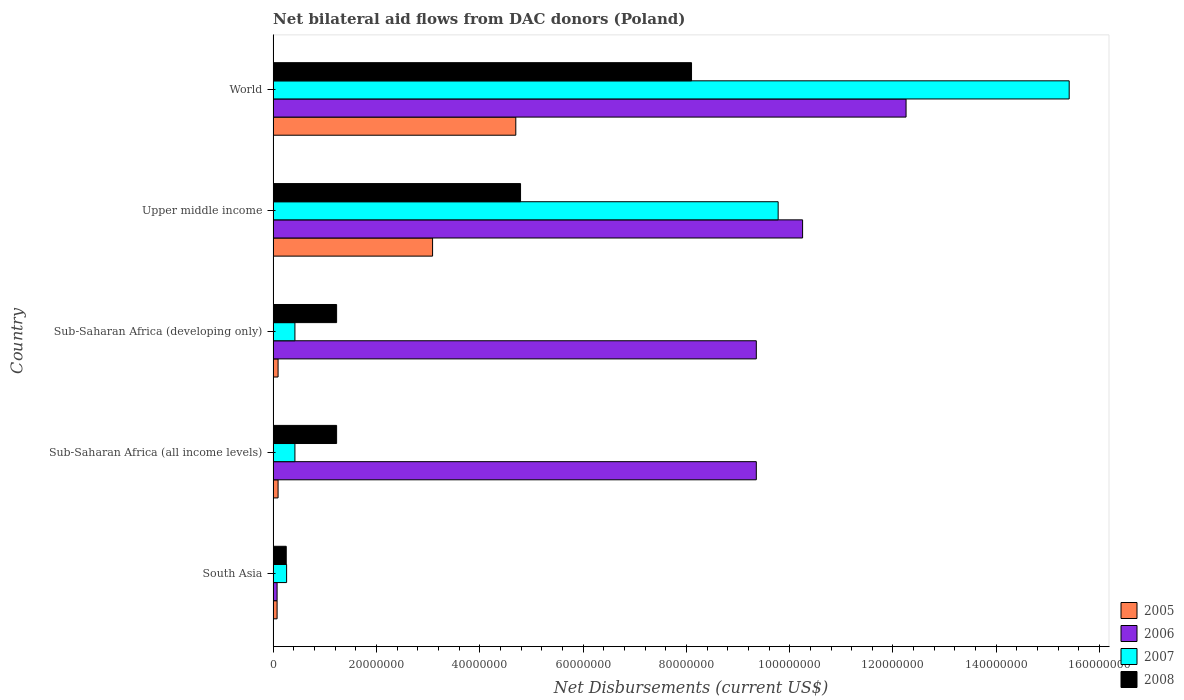How many groups of bars are there?
Provide a succinct answer. 5. Are the number of bars on each tick of the Y-axis equal?
Ensure brevity in your answer.  Yes. How many bars are there on the 1st tick from the top?
Ensure brevity in your answer.  4. How many bars are there on the 5th tick from the bottom?
Your answer should be very brief. 4. What is the label of the 3rd group of bars from the top?
Ensure brevity in your answer.  Sub-Saharan Africa (developing only). What is the net bilateral aid flows in 2005 in Sub-Saharan Africa (all income levels)?
Offer a terse response. 9.60e+05. Across all countries, what is the maximum net bilateral aid flows in 2008?
Offer a terse response. 8.10e+07. Across all countries, what is the minimum net bilateral aid flows in 2007?
Ensure brevity in your answer.  2.61e+06. In which country was the net bilateral aid flows in 2007 maximum?
Keep it short and to the point. World. What is the total net bilateral aid flows in 2005 in the graph?
Make the answer very short. 8.05e+07. What is the difference between the net bilateral aid flows in 2008 in Sub-Saharan Africa (developing only) and that in World?
Offer a very short reply. -6.87e+07. What is the difference between the net bilateral aid flows in 2007 in World and the net bilateral aid flows in 2008 in Upper middle income?
Make the answer very short. 1.06e+08. What is the average net bilateral aid flows in 2007 per country?
Offer a terse response. 5.26e+07. What is the difference between the net bilateral aid flows in 2008 and net bilateral aid flows in 2005 in South Asia?
Keep it short and to the point. 1.77e+06. What is the ratio of the net bilateral aid flows in 2007 in Sub-Saharan Africa (developing only) to that in Upper middle income?
Give a very brief answer. 0.04. What is the difference between the highest and the second highest net bilateral aid flows in 2007?
Offer a terse response. 5.63e+07. What is the difference between the highest and the lowest net bilateral aid flows in 2008?
Your answer should be compact. 7.85e+07. In how many countries, is the net bilateral aid flows in 2008 greater than the average net bilateral aid flows in 2008 taken over all countries?
Keep it short and to the point. 2. Is the sum of the net bilateral aid flows in 2008 in Upper middle income and World greater than the maximum net bilateral aid flows in 2007 across all countries?
Provide a short and direct response. No. What does the 1st bar from the top in Sub-Saharan Africa (all income levels) represents?
Make the answer very short. 2008. How many countries are there in the graph?
Keep it short and to the point. 5. What is the difference between two consecutive major ticks on the X-axis?
Ensure brevity in your answer.  2.00e+07. Are the values on the major ticks of X-axis written in scientific E-notation?
Offer a terse response. No. Does the graph contain any zero values?
Your answer should be very brief. No. Does the graph contain grids?
Ensure brevity in your answer.  No. How many legend labels are there?
Provide a short and direct response. 4. How are the legend labels stacked?
Your response must be concise. Vertical. What is the title of the graph?
Your response must be concise. Net bilateral aid flows from DAC donors (Poland). Does "1964" appear as one of the legend labels in the graph?
Your answer should be compact. No. What is the label or title of the X-axis?
Offer a very short reply. Net Disbursements (current US$). What is the Net Disbursements (current US$) of 2005 in South Asia?
Offer a very short reply. 7.70e+05. What is the Net Disbursements (current US$) of 2006 in South Asia?
Ensure brevity in your answer.  7.70e+05. What is the Net Disbursements (current US$) of 2007 in South Asia?
Your answer should be very brief. 2.61e+06. What is the Net Disbursements (current US$) of 2008 in South Asia?
Keep it short and to the point. 2.54e+06. What is the Net Disbursements (current US$) in 2005 in Sub-Saharan Africa (all income levels)?
Ensure brevity in your answer.  9.60e+05. What is the Net Disbursements (current US$) of 2006 in Sub-Saharan Africa (all income levels)?
Your answer should be compact. 9.35e+07. What is the Net Disbursements (current US$) of 2007 in Sub-Saharan Africa (all income levels)?
Your answer should be very brief. 4.22e+06. What is the Net Disbursements (current US$) in 2008 in Sub-Saharan Africa (all income levels)?
Ensure brevity in your answer.  1.23e+07. What is the Net Disbursements (current US$) of 2005 in Sub-Saharan Africa (developing only)?
Provide a short and direct response. 9.60e+05. What is the Net Disbursements (current US$) of 2006 in Sub-Saharan Africa (developing only)?
Your answer should be very brief. 9.35e+07. What is the Net Disbursements (current US$) in 2007 in Sub-Saharan Africa (developing only)?
Provide a succinct answer. 4.22e+06. What is the Net Disbursements (current US$) in 2008 in Sub-Saharan Africa (developing only)?
Offer a very short reply. 1.23e+07. What is the Net Disbursements (current US$) in 2005 in Upper middle income?
Offer a terse response. 3.09e+07. What is the Net Disbursements (current US$) in 2006 in Upper middle income?
Offer a terse response. 1.02e+08. What is the Net Disbursements (current US$) of 2007 in Upper middle income?
Provide a succinct answer. 9.78e+07. What is the Net Disbursements (current US$) in 2008 in Upper middle income?
Provide a succinct answer. 4.79e+07. What is the Net Disbursements (current US$) in 2005 in World?
Keep it short and to the point. 4.70e+07. What is the Net Disbursements (current US$) of 2006 in World?
Your response must be concise. 1.23e+08. What is the Net Disbursements (current US$) in 2007 in World?
Offer a terse response. 1.54e+08. What is the Net Disbursements (current US$) of 2008 in World?
Provide a short and direct response. 8.10e+07. Across all countries, what is the maximum Net Disbursements (current US$) of 2005?
Make the answer very short. 4.70e+07. Across all countries, what is the maximum Net Disbursements (current US$) of 2006?
Give a very brief answer. 1.23e+08. Across all countries, what is the maximum Net Disbursements (current US$) of 2007?
Provide a succinct answer. 1.54e+08. Across all countries, what is the maximum Net Disbursements (current US$) of 2008?
Keep it short and to the point. 8.10e+07. Across all countries, what is the minimum Net Disbursements (current US$) of 2005?
Keep it short and to the point. 7.70e+05. Across all countries, what is the minimum Net Disbursements (current US$) in 2006?
Offer a terse response. 7.70e+05. Across all countries, what is the minimum Net Disbursements (current US$) of 2007?
Your answer should be compact. 2.61e+06. Across all countries, what is the minimum Net Disbursements (current US$) in 2008?
Offer a very short reply. 2.54e+06. What is the total Net Disbursements (current US$) of 2005 in the graph?
Give a very brief answer. 8.05e+07. What is the total Net Disbursements (current US$) in 2006 in the graph?
Offer a very short reply. 4.13e+08. What is the total Net Disbursements (current US$) of 2007 in the graph?
Your answer should be compact. 2.63e+08. What is the total Net Disbursements (current US$) in 2008 in the graph?
Provide a succinct answer. 1.56e+08. What is the difference between the Net Disbursements (current US$) in 2006 in South Asia and that in Sub-Saharan Africa (all income levels)?
Your answer should be very brief. -9.28e+07. What is the difference between the Net Disbursements (current US$) in 2007 in South Asia and that in Sub-Saharan Africa (all income levels)?
Your response must be concise. -1.61e+06. What is the difference between the Net Disbursements (current US$) in 2008 in South Asia and that in Sub-Saharan Africa (all income levels)?
Offer a very short reply. -9.75e+06. What is the difference between the Net Disbursements (current US$) of 2005 in South Asia and that in Sub-Saharan Africa (developing only)?
Give a very brief answer. -1.90e+05. What is the difference between the Net Disbursements (current US$) in 2006 in South Asia and that in Sub-Saharan Africa (developing only)?
Your response must be concise. -9.28e+07. What is the difference between the Net Disbursements (current US$) of 2007 in South Asia and that in Sub-Saharan Africa (developing only)?
Provide a short and direct response. -1.61e+06. What is the difference between the Net Disbursements (current US$) in 2008 in South Asia and that in Sub-Saharan Africa (developing only)?
Ensure brevity in your answer.  -9.75e+06. What is the difference between the Net Disbursements (current US$) of 2005 in South Asia and that in Upper middle income?
Give a very brief answer. -3.01e+07. What is the difference between the Net Disbursements (current US$) of 2006 in South Asia and that in Upper middle income?
Your answer should be compact. -1.02e+08. What is the difference between the Net Disbursements (current US$) of 2007 in South Asia and that in Upper middle income?
Offer a very short reply. -9.52e+07. What is the difference between the Net Disbursements (current US$) in 2008 in South Asia and that in Upper middle income?
Keep it short and to the point. -4.54e+07. What is the difference between the Net Disbursements (current US$) of 2005 in South Asia and that in World?
Offer a terse response. -4.62e+07. What is the difference between the Net Disbursements (current US$) in 2006 in South Asia and that in World?
Your answer should be compact. -1.22e+08. What is the difference between the Net Disbursements (current US$) in 2007 in South Asia and that in World?
Offer a very short reply. -1.52e+08. What is the difference between the Net Disbursements (current US$) in 2008 in South Asia and that in World?
Ensure brevity in your answer.  -7.85e+07. What is the difference between the Net Disbursements (current US$) in 2005 in Sub-Saharan Africa (all income levels) and that in Sub-Saharan Africa (developing only)?
Your response must be concise. 0. What is the difference between the Net Disbursements (current US$) of 2007 in Sub-Saharan Africa (all income levels) and that in Sub-Saharan Africa (developing only)?
Give a very brief answer. 0. What is the difference between the Net Disbursements (current US$) of 2008 in Sub-Saharan Africa (all income levels) and that in Sub-Saharan Africa (developing only)?
Provide a succinct answer. 0. What is the difference between the Net Disbursements (current US$) of 2005 in Sub-Saharan Africa (all income levels) and that in Upper middle income?
Give a very brief answer. -2.99e+07. What is the difference between the Net Disbursements (current US$) in 2006 in Sub-Saharan Africa (all income levels) and that in Upper middle income?
Provide a short and direct response. -8.96e+06. What is the difference between the Net Disbursements (current US$) in 2007 in Sub-Saharan Africa (all income levels) and that in Upper middle income?
Your answer should be compact. -9.36e+07. What is the difference between the Net Disbursements (current US$) in 2008 in Sub-Saharan Africa (all income levels) and that in Upper middle income?
Keep it short and to the point. -3.56e+07. What is the difference between the Net Disbursements (current US$) of 2005 in Sub-Saharan Africa (all income levels) and that in World?
Provide a succinct answer. -4.60e+07. What is the difference between the Net Disbursements (current US$) in 2006 in Sub-Saharan Africa (all income levels) and that in World?
Provide a succinct answer. -2.90e+07. What is the difference between the Net Disbursements (current US$) of 2007 in Sub-Saharan Africa (all income levels) and that in World?
Your answer should be very brief. -1.50e+08. What is the difference between the Net Disbursements (current US$) of 2008 in Sub-Saharan Africa (all income levels) and that in World?
Make the answer very short. -6.87e+07. What is the difference between the Net Disbursements (current US$) in 2005 in Sub-Saharan Africa (developing only) and that in Upper middle income?
Provide a short and direct response. -2.99e+07. What is the difference between the Net Disbursements (current US$) in 2006 in Sub-Saharan Africa (developing only) and that in Upper middle income?
Your response must be concise. -8.96e+06. What is the difference between the Net Disbursements (current US$) in 2007 in Sub-Saharan Africa (developing only) and that in Upper middle income?
Offer a terse response. -9.36e+07. What is the difference between the Net Disbursements (current US$) in 2008 in Sub-Saharan Africa (developing only) and that in Upper middle income?
Give a very brief answer. -3.56e+07. What is the difference between the Net Disbursements (current US$) in 2005 in Sub-Saharan Africa (developing only) and that in World?
Ensure brevity in your answer.  -4.60e+07. What is the difference between the Net Disbursements (current US$) in 2006 in Sub-Saharan Africa (developing only) and that in World?
Provide a succinct answer. -2.90e+07. What is the difference between the Net Disbursements (current US$) in 2007 in Sub-Saharan Africa (developing only) and that in World?
Your answer should be compact. -1.50e+08. What is the difference between the Net Disbursements (current US$) of 2008 in Sub-Saharan Africa (developing only) and that in World?
Give a very brief answer. -6.87e+07. What is the difference between the Net Disbursements (current US$) of 2005 in Upper middle income and that in World?
Provide a succinct answer. -1.61e+07. What is the difference between the Net Disbursements (current US$) in 2006 in Upper middle income and that in World?
Your answer should be very brief. -2.00e+07. What is the difference between the Net Disbursements (current US$) in 2007 in Upper middle income and that in World?
Provide a short and direct response. -5.63e+07. What is the difference between the Net Disbursements (current US$) in 2008 in Upper middle income and that in World?
Give a very brief answer. -3.31e+07. What is the difference between the Net Disbursements (current US$) of 2005 in South Asia and the Net Disbursements (current US$) of 2006 in Sub-Saharan Africa (all income levels)?
Keep it short and to the point. -9.28e+07. What is the difference between the Net Disbursements (current US$) in 2005 in South Asia and the Net Disbursements (current US$) in 2007 in Sub-Saharan Africa (all income levels)?
Ensure brevity in your answer.  -3.45e+06. What is the difference between the Net Disbursements (current US$) of 2005 in South Asia and the Net Disbursements (current US$) of 2008 in Sub-Saharan Africa (all income levels)?
Your answer should be very brief. -1.15e+07. What is the difference between the Net Disbursements (current US$) in 2006 in South Asia and the Net Disbursements (current US$) in 2007 in Sub-Saharan Africa (all income levels)?
Offer a very short reply. -3.45e+06. What is the difference between the Net Disbursements (current US$) in 2006 in South Asia and the Net Disbursements (current US$) in 2008 in Sub-Saharan Africa (all income levels)?
Provide a short and direct response. -1.15e+07. What is the difference between the Net Disbursements (current US$) of 2007 in South Asia and the Net Disbursements (current US$) of 2008 in Sub-Saharan Africa (all income levels)?
Offer a very short reply. -9.68e+06. What is the difference between the Net Disbursements (current US$) in 2005 in South Asia and the Net Disbursements (current US$) in 2006 in Sub-Saharan Africa (developing only)?
Ensure brevity in your answer.  -9.28e+07. What is the difference between the Net Disbursements (current US$) of 2005 in South Asia and the Net Disbursements (current US$) of 2007 in Sub-Saharan Africa (developing only)?
Provide a short and direct response. -3.45e+06. What is the difference between the Net Disbursements (current US$) of 2005 in South Asia and the Net Disbursements (current US$) of 2008 in Sub-Saharan Africa (developing only)?
Provide a short and direct response. -1.15e+07. What is the difference between the Net Disbursements (current US$) in 2006 in South Asia and the Net Disbursements (current US$) in 2007 in Sub-Saharan Africa (developing only)?
Keep it short and to the point. -3.45e+06. What is the difference between the Net Disbursements (current US$) of 2006 in South Asia and the Net Disbursements (current US$) of 2008 in Sub-Saharan Africa (developing only)?
Offer a terse response. -1.15e+07. What is the difference between the Net Disbursements (current US$) of 2007 in South Asia and the Net Disbursements (current US$) of 2008 in Sub-Saharan Africa (developing only)?
Your answer should be very brief. -9.68e+06. What is the difference between the Net Disbursements (current US$) of 2005 in South Asia and the Net Disbursements (current US$) of 2006 in Upper middle income?
Give a very brief answer. -1.02e+08. What is the difference between the Net Disbursements (current US$) of 2005 in South Asia and the Net Disbursements (current US$) of 2007 in Upper middle income?
Provide a succinct answer. -9.70e+07. What is the difference between the Net Disbursements (current US$) in 2005 in South Asia and the Net Disbursements (current US$) in 2008 in Upper middle income?
Give a very brief answer. -4.71e+07. What is the difference between the Net Disbursements (current US$) of 2006 in South Asia and the Net Disbursements (current US$) of 2007 in Upper middle income?
Provide a short and direct response. -9.70e+07. What is the difference between the Net Disbursements (current US$) of 2006 in South Asia and the Net Disbursements (current US$) of 2008 in Upper middle income?
Give a very brief answer. -4.71e+07. What is the difference between the Net Disbursements (current US$) in 2007 in South Asia and the Net Disbursements (current US$) in 2008 in Upper middle income?
Your response must be concise. -4.53e+07. What is the difference between the Net Disbursements (current US$) in 2005 in South Asia and the Net Disbursements (current US$) in 2006 in World?
Your answer should be very brief. -1.22e+08. What is the difference between the Net Disbursements (current US$) in 2005 in South Asia and the Net Disbursements (current US$) in 2007 in World?
Make the answer very short. -1.53e+08. What is the difference between the Net Disbursements (current US$) of 2005 in South Asia and the Net Disbursements (current US$) of 2008 in World?
Give a very brief answer. -8.02e+07. What is the difference between the Net Disbursements (current US$) in 2006 in South Asia and the Net Disbursements (current US$) in 2007 in World?
Offer a very short reply. -1.53e+08. What is the difference between the Net Disbursements (current US$) of 2006 in South Asia and the Net Disbursements (current US$) of 2008 in World?
Your answer should be very brief. -8.02e+07. What is the difference between the Net Disbursements (current US$) of 2007 in South Asia and the Net Disbursements (current US$) of 2008 in World?
Provide a short and direct response. -7.84e+07. What is the difference between the Net Disbursements (current US$) in 2005 in Sub-Saharan Africa (all income levels) and the Net Disbursements (current US$) in 2006 in Sub-Saharan Africa (developing only)?
Provide a succinct answer. -9.26e+07. What is the difference between the Net Disbursements (current US$) of 2005 in Sub-Saharan Africa (all income levels) and the Net Disbursements (current US$) of 2007 in Sub-Saharan Africa (developing only)?
Provide a short and direct response. -3.26e+06. What is the difference between the Net Disbursements (current US$) in 2005 in Sub-Saharan Africa (all income levels) and the Net Disbursements (current US$) in 2008 in Sub-Saharan Africa (developing only)?
Your answer should be compact. -1.13e+07. What is the difference between the Net Disbursements (current US$) in 2006 in Sub-Saharan Africa (all income levels) and the Net Disbursements (current US$) in 2007 in Sub-Saharan Africa (developing only)?
Your answer should be compact. 8.93e+07. What is the difference between the Net Disbursements (current US$) of 2006 in Sub-Saharan Africa (all income levels) and the Net Disbursements (current US$) of 2008 in Sub-Saharan Africa (developing only)?
Offer a terse response. 8.12e+07. What is the difference between the Net Disbursements (current US$) of 2007 in Sub-Saharan Africa (all income levels) and the Net Disbursements (current US$) of 2008 in Sub-Saharan Africa (developing only)?
Give a very brief answer. -8.07e+06. What is the difference between the Net Disbursements (current US$) of 2005 in Sub-Saharan Africa (all income levels) and the Net Disbursements (current US$) of 2006 in Upper middle income?
Your answer should be very brief. -1.02e+08. What is the difference between the Net Disbursements (current US$) in 2005 in Sub-Saharan Africa (all income levels) and the Net Disbursements (current US$) in 2007 in Upper middle income?
Your answer should be very brief. -9.68e+07. What is the difference between the Net Disbursements (current US$) in 2005 in Sub-Saharan Africa (all income levels) and the Net Disbursements (current US$) in 2008 in Upper middle income?
Keep it short and to the point. -4.69e+07. What is the difference between the Net Disbursements (current US$) in 2006 in Sub-Saharan Africa (all income levels) and the Net Disbursements (current US$) in 2007 in Upper middle income?
Offer a very short reply. -4.23e+06. What is the difference between the Net Disbursements (current US$) in 2006 in Sub-Saharan Africa (all income levels) and the Net Disbursements (current US$) in 2008 in Upper middle income?
Keep it short and to the point. 4.56e+07. What is the difference between the Net Disbursements (current US$) in 2007 in Sub-Saharan Africa (all income levels) and the Net Disbursements (current US$) in 2008 in Upper middle income?
Provide a succinct answer. -4.37e+07. What is the difference between the Net Disbursements (current US$) in 2005 in Sub-Saharan Africa (all income levels) and the Net Disbursements (current US$) in 2006 in World?
Keep it short and to the point. -1.22e+08. What is the difference between the Net Disbursements (current US$) in 2005 in Sub-Saharan Africa (all income levels) and the Net Disbursements (current US$) in 2007 in World?
Ensure brevity in your answer.  -1.53e+08. What is the difference between the Net Disbursements (current US$) of 2005 in Sub-Saharan Africa (all income levels) and the Net Disbursements (current US$) of 2008 in World?
Offer a terse response. -8.00e+07. What is the difference between the Net Disbursements (current US$) of 2006 in Sub-Saharan Africa (all income levels) and the Net Disbursements (current US$) of 2007 in World?
Give a very brief answer. -6.06e+07. What is the difference between the Net Disbursements (current US$) in 2006 in Sub-Saharan Africa (all income levels) and the Net Disbursements (current US$) in 2008 in World?
Your answer should be compact. 1.25e+07. What is the difference between the Net Disbursements (current US$) of 2007 in Sub-Saharan Africa (all income levels) and the Net Disbursements (current US$) of 2008 in World?
Keep it short and to the point. -7.68e+07. What is the difference between the Net Disbursements (current US$) in 2005 in Sub-Saharan Africa (developing only) and the Net Disbursements (current US$) in 2006 in Upper middle income?
Make the answer very short. -1.02e+08. What is the difference between the Net Disbursements (current US$) of 2005 in Sub-Saharan Africa (developing only) and the Net Disbursements (current US$) of 2007 in Upper middle income?
Your answer should be very brief. -9.68e+07. What is the difference between the Net Disbursements (current US$) in 2005 in Sub-Saharan Africa (developing only) and the Net Disbursements (current US$) in 2008 in Upper middle income?
Your response must be concise. -4.69e+07. What is the difference between the Net Disbursements (current US$) of 2006 in Sub-Saharan Africa (developing only) and the Net Disbursements (current US$) of 2007 in Upper middle income?
Your answer should be very brief. -4.23e+06. What is the difference between the Net Disbursements (current US$) of 2006 in Sub-Saharan Africa (developing only) and the Net Disbursements (current US$) of 2008 in Upper middle income?
Offer a terse response. 4.56e+07. What is the difference between the Net Disbursements (current US$) in 2007 in Sub-Saharan Africa (developing only) and the Net Disbursements (current US$) in 2008 in Upper middle income?
Your response must be concise. -4.37e+07. What is the difference between the Net Disbursements (current US$) of 2005 in Sub-Saharan Africa (developing only) and the Net Disbursements (current US$) of 2006 in World?
Ensure brevity in your answer.  -1.22e+08. What is the difference between the Net Disbursements (current US$) of 2005 in Sub-Saharan Africa (developing only) and the Net Disbursements (current US$) of 2007 in World?
Give a very brief answer. -1.53e+08. What is the difference between the Net Disbursements (current US$) of 2005 in Sub-Saharan Africa (developing only) and the Net Disbursements (current US$) of 2008 in World?
Offer a very short reply. -8.00e+07. What is the difference between the Net Disbursements (current US$) in 2006 in Sub-Saharan Africa (developing only) and the Net Disbursements (current US$) in 2007 in World?
Your answer should be very brief. -6.06e+07. What is the difference between the Net Disbursements (current US$) of 2006 in Sub-Saharan Africa (developing only) and the Net Disbursements (current US$) of 2008 in World?
Ensure brevity in your answer.  1.25e+07. What is the difference between the Net Disbursements (current US$) of 2007 in Sub-Saharan Africa (developing only) and the Net Disbursements (current US$) of 2008 in World?
Keep it short and to the point. -7.68e+07. What is the difference between the Net Disbursements (current US$) in 2005 in Upper middle income and the Net Disbursements (current US$) in 2006 in World?
Ensure brevity in your answer.  -9.17e+07. What is the difference between the Net Disbursements (current US$) in 2005 in Upper middle income and the Net Disbursements (current US$) in 2007 in World?
Your answer should be compact. -1.23e+08. What is the difference between the Net Disbursements (current US$) in 2005 in Upper middle income and the Net Disbursements (current US$) in 2008 in World?
Keep it short and to the point. -5.01e+07. What is the difference between the Net Disbursements (current US$) of 2006 in Upper middle income and the Net Disbursements (current US$) of 2007 in World?
Offer a terse response. -5.16e+07. What is the difference between the Net Disbursements (current US$) in 2006 in Upper middle income and the Net Disbursements (current US$) in 2008 in World?
Your response must be concise. 2.15e+07. What is the difference between the Net Disbursements (current US$) of 2007 in Upper middle income and the Net Disbursements (current US$) of 2008 in World?
Your response must be concise. 1.68e+07. What is the average Net Disbursements (current US$) in 2005 per country?
Ensure brevity in your answer.  1.61e+07. What is the average Net Disbursements (current US$) in 2006 per country?
Offer a terse response. 8.26e+07. What is the average Net Disbursements (current US$) in 2007 per country?
Offer a very short reply. 5.26e+07. What is the average Net Disbursements (current US$) in 2008 per country?
Offer a terse response. 3.12e+07. What is the difference between the Net Disbursements (current US$) of 2005 and Net Disbursements (current US$) of 2007 in South Asia?
Your answer should be very brief. -1.84e+06. What is the difference between the Net Disbursements (current US$) in 2005 and Net Disbursements (current US$) in 2008 in South Asia?
Make the answer very short. -1.77e+06. What is the difference between the Net Disbursements (current US$) of 2006 and Net Disbursements (current US$) of 2007 in South Asia?
Your answer should be compact. -1.84e+06. What is the difference between the Net Disbursements (current US$) of 2006 and Net Disbursements (current US$) of 2008 in South Asia?
Give a very brief answer. -1.77e+06. What is the difference between the Net Disbursements (current US$) of 2005 and Net Disbursements (current US$) of 2006 in Sub-Saharan Africa (all income levels)?
Your response must be concise. -9.26e+07. What is the difference between the Net Disbursements (current US$) in 2005 and Net Disbursements (current US$) in 2007 in Sub-Saharan Africa (all income levels)?
Give a very brief answer. -3.26e+06. What is the difference between the Net Disbursements (current US$) in 2005 and Net Disbursements (current US$) in 2008 in Sub-Saharan Africa (all income levels)?
Keep it short and to the point. -1.13e+07. What is the difference between the Net Disbursements (current US$) in 2006 and Net Disbursements (current US$) in 2007 in Sub-Saharan Africa (all income levels)?
Ensure brevity in your answer.  8.93e+07. What is the difference between the Net Disbursements (current US$) of 2006 and Net Disbursements (current US$) of 2008 in Sub-Saharan Africa (all income levels)?
Your answer should be very brief. 8.12e+07. What is the difference between the Net Disbursements (current US$) of 2007 and Net Disbursements (current US$) of 2008 in Sub-Saharan Africa (all income levels)?
Make the answer very short. -8.07e+06. What is the difference between the Net Disbursements (current US$) in 2005 and Net Disbursements (current US$) in 2006 in Sub-Saharan Africa (developing only)?
Make the answer very short. -9.26e+07. What is the difference between the Net Disbursements (current US$) of 2005 and Net Disbursements (current US$) of 2007 in Sub-Saharan Africa (developing only)?
Give a very brief answer. -3.26e+06. What is the difference between the Net Disbursements (current US$) in 2005 and Net Disbursements (current US$) in 2008 in Sub-Saharan Africa (developing only)?
Provide a short and direct response. -1.13e+07. What is the difference between the Net Disbursements (current US$) of 2006 and Net Disbursements (current US$) of 2007 in Sub-Saharan Africa (developing only)?
Provide a succinct answer. 8.93e+07. What is the difference between the Net Disbursements (current US$) in 2006 and Net Disbursements (current US$) in 2008 in Sub-Saharan Africa (developing only)?
Give a very brief answer. 8.12e+07. What is the difference between the Net Disbursements (current US$) of 2007 and Net Disbursements (current US$) of 2008 in Sub-Saharan Africa (developing only)?
Your answer should be very brief. -8.07e+06. What is the difference between the Net Disbursements (current US$) in 2005 and Net Disbursements (current US$) in 2006 in Upper middle income?
Offer a very short reply. -7.16e+07. What is the difference between the Net Disbursements (current US$) in 2005 and Net Disbursements (current US$) in 2007 in Upper middle income?
Keep it short and to the point. -6.69e+07. What is the difference between the Net Disbursements (current US$) of 2005 and Net Disbursements (current US$) of 2008 in Upper middle income?
Give a very brief answer. -1.70e+07. What is the difference between the Net Disbursements (current US$) of 2006 and Net Disbursements (current US$) of 2007 in Upper middle income?
Offer a terse response. 4.73e+06. What is the difference between the Net Disbursements (current US$) of 2006 and Net Disbursements (current US$) of 2008 in Upper middle income?
Your response must be concise. 5.46e+07. What is the difference between the Net Disbursements (current US$) of 2007 and Net Disbursements (current US$) of 2008 in Upper middle income?
Make the answer very short. 4.99e+07. What is the difference between the Net Disbursements (current US$) of 2005 and Net Disbursements (current US$) of 2006 in World?
Make the answer very short. -7.56e+07. What is the difference between the Net Disbursements (current US$) of 2005 and Net Disbursements (current US$) of 2007 in World?
Your answer should be very brief. -1.07e+08. What is the difference between the Net Disbursements (current US$) of 2005 and Net Disbursements (current US$) of 2008 in World?
Your answer should be compact. -3.40e+07. What is the difference between the Net Disbursements (current US$) of 2006 and Net Disbursements (current US$) of 2007 in World?
Offer a very short reply. -3.16e+07. What is the difference between the Net Disbursements (current US$) of 2006 and Net Disbursements (current US$) of 2008 in World?
Give a very brief answer. 4.15e+07. What is the difference between the Net Disbursements (current US$) in 2007 and Net Disbursements (current US$) in 2008 in World?
Your response must be concise. 7.31e+07. What is the ratio of the Net Disbursements (current US$) in 2005 in South Asia to that in Sub-Saharan Africa (all income levels)?
Make the answer very short. 0.8. What is the ratio of the Net Disbursements (current US$) in 2006 in South Asia to that in Sub-Saharan Africa (all income levels)?
Ensure brevity in your answer.  0.01. What is the ratio of the Net Disbursements (current US$) of 2007 in South Asia to that in Sub-Saharan Africa (all income levels)?
Your answer should be compact. 0.62. What is the ratio of the Net Disbursements (current US$) in 2008 in South Asia to that in Sub-Saharan Africa (all income levels)?
Your answer should be compact. 0.21. What is the ratio of the Net Disbursements (current US$) in 2005 in South Asia to that in Sub-Saharan Africa (developing only)?
Provide a succinct answer. 0.8. What is the ratio of the Net Disbursements (current US$) in 2006 in South Asia to that in Sub-Saharan Africa (developing only)?
Your answer should be very brief. 0.01. What is the ratio of the Net Disbursements (current US$) in 2007 in South Asia to that in Sub-Saharan Africa (developing only)?
Ensure brevity in your answer.  0.62. What is the ratio of the Net Disbursements (current US$) in 2008 in South Asia to that in Sub-Saharan Africa (developing only)?
Make the answer very short. 0.21. What is the ratio of the Net Disbursements (current US$) of 2005 in South Asia to that in Upper middle income?
Provide a short and direct response. 0.02. What is the ratio of the Net Disbursements (current US$) of 2006 in South Asia to that in Upper middle income?
Provide a short and direct response. 0.01. What is the ratio of the Net Disbursements (current US$) in 2007 in South Asia to that in Upper middle income?
Keep it short and to the point. 0.03. What is the ratio of the Net Disbursements (current US$) in 2008 in South Asia to that in Upper middle income?
Give a very brief answer. 0.05. What is the ratio of the Net Disbursements (current US$) in 2005 in South Asia to that in World?
Your answer should be compact. 0.02. What is the ratio of the Net Disbursements (current US$) in 2006 in South Asia to that in World?
Provide a succinct answer. 0.01. What is the ratio of the Net Disbursements (current US$) in 2007 in South Asia to that in World?
Your answer should be very brief. 0.02. What is the ratio of the Net Disbursements (current US$) of 2008 in South Asia to that in World?
Your answer should be very brief. 0.03. What is the ratio of the Net Disbursements (current US$) of 2007 in Sub-Saharan Africa (all income levels) to that in Sub-Saharan Africa (developing only)?
Your answer should be compact. 1. What is the ratio of the Net Disbursements (current US$) of 2008 in Sub-Saharan Africa (all income levels) to that in Sub-Saharan Africa (developing only)?
Offer a terse response. 1. What is the ratio of the Net Disbursements (current US$) in 2005 in Sub-Saharan Africa (all income levels) to that in Upper middle income?
Make the answer very short. 0.03. What is the ratio of the Net Disbursements (current US$) of 2006 in Sub-Saharan Africa (all income levels) to that in Upper middle income?
Your answer should be compact. 0.91. What is the ratio of the Net Disbursements (current US$) of 2007 in Sub-Saharan Africa (all income levels) to that in Upper middle income?
Your answer should be very brief. 0.04. What is the ratio of the Net Disbursements (current US$) of 2008 in Sub-Saharan Africa (all income levels) to that in Upper middle income?
Provide a short and direct response. 0.26. What is the ratio of the Net Disbursements (current US$) of 2005 in Sub-Saharan Africa (all income levels) to that in World?
Ensure brevity in your answer.  0.02. What is the ratio of the Net Disbursements (current US$) of 2006 in Sub-Saharan Africa (all income levels) to that in World?
Give a very brief answer. 0.76. What is the ratio of the Net Disbursements (current US$) in 2007 in Sub-Saharan Africa (all income levels) to that in World?
Provide a succinct answer. 0.03. What is the ratio of the Net Disbursements (current US$) of 2008 in Sub-Saharan Africa (all income levels) to that in World?
Provide a succinct answer. 0.15. What is the ratio of the Net Disbursements (current US$) of 2005 in Sub-Saharan Africa (developing only) to that in Upper middle income?
Provide a short and direct response. 0.03. What is the ratio of the Net Disbursements (current US$) in 2006 in Sub-Saharan Africa (developing only) to that in Upper middle income?
Ensure brevity in your answer.  0.91. What is the ratio of the Net Disbursements (current US$) of 2007 in Sub-Saharan Africa (developing only) to that in Upper middle income?
Offer a terse response. 0.04. What is the ratio of the Net Disbursements (current US$) in 2008 in Sub-Saharan Africa (developing only) to that in Upper middle income?
Provide a succinct answer. 0.26. What is the ratio of the Net Disbursements (current US$) of 2005 in Sub-Saharan Africa (developing only) to that in World?
Your response must be concise. 0.02. What is the ratio of the Net Disbursements (current US$) of 2006 in Sub-Saharan Africa (developing only) to that in World?
Your response must be concise. 0.76. What is the ratio of the Net Disbursements (current US$) in 2007 in Sub-Saharan Africa (developing only) to that in World?
Your answer should be very brief. 0.03. What is the ratio of the Net Disbursements (current US$) of 2008 in Sub-Saharan Africa (developing only) to that in World?
Ensure brevity in your answer.  0.15. What is the ratio of the Net Disbursements (current US$) in 2005 in Upper middle income to that in World?
Give a very brief answer. 0.66. What is the ratio of the Net Disbursements (current US$) in 2006 in Upper middle income to that in World?
Your answer should be very brief. 0.84. What is the ratio of the Net Disbursements (current US$) of 2007 in Upper middle income to that in World?
Provide a short and direct response. 0.63. What is the ratio of the Net Disbursements (current US$) in 2008 in Upper middle income to that in World?
Your answer should be compact. 0.59. What is the difference between the highest and the second highest Net Disbursements (current US$) of 2005?
Make the answer very short. 1.61e+07. What is the difference between the highest and the second highest Net Disbursements (current US$) of 2006?
Keep it short and to the point. 2.00e+07. What is the difference between the highest and the second highest Net Disbursements (current US$) of 2007?
Keep it short and to the point. 5.63e+07. What is the difference between the highest and the second highest Net Disbursements (current US$) of 2008?
Provide a succinct answer. 3.31e+07. What is the difference between the highest and the lowest Net Disbursements (current US$) of 2005?
Offer a very short reply. 4.62e+07. What is the difference between the highest and the lowest Net Disbursements (current US$) of 2006?
Your response must be concise. 1.22e+08. What is the difference between the highest and the lowest Net Disbursements (current US$) in 2007?
Offer a terse response. 1.52e+08. What is the difference between the highest and the lowest Net Disbursements (current US$) in 2008?
Your response must be concise. 7.85e+07. 